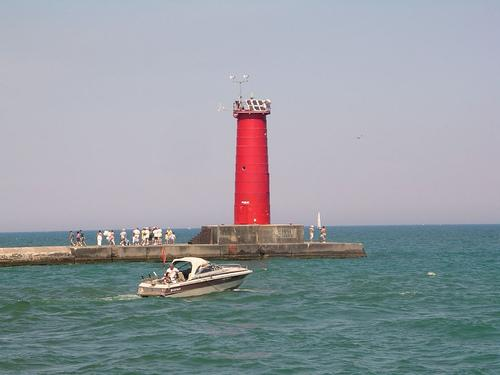What purpose does the red tower serve?

Choices:
A) toll taking
B) aquarium
C) warning ships
D) prison warning ships 